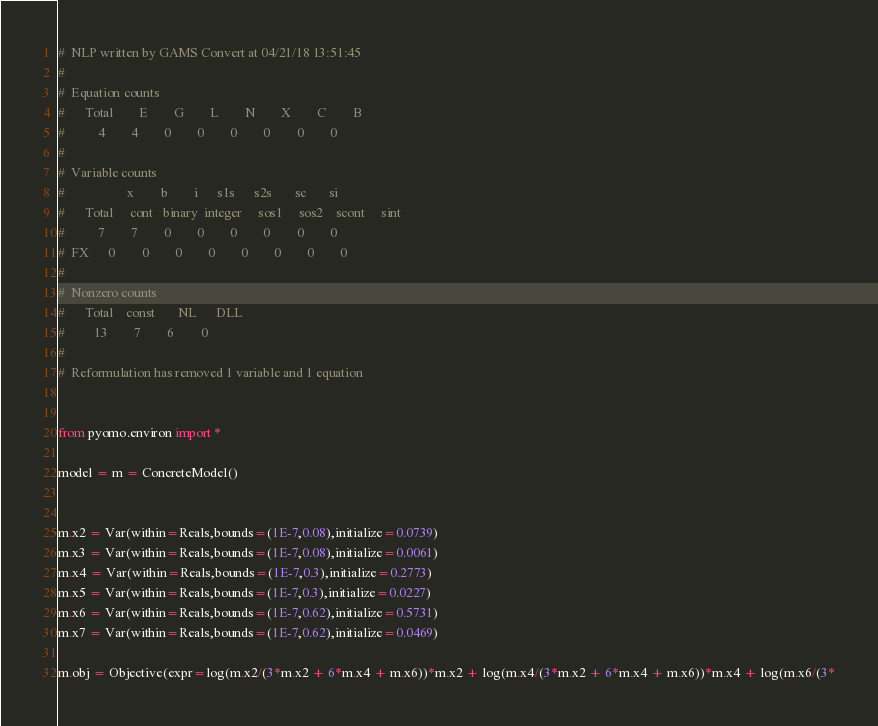<code> <loc_0><loc_0><loc_500><loc_500><_Python_>#  NLP written by GAMS Convert at 04/21/18 13:51:45
#  
#  Equation counts
#      Total        E        G        L        N        X        C        B
#          4        4        0        0        0        0        0        0
#  
#  Variable counts
#                   x        b        i      s1s      s2s       sc       si
#      Total     cont   binary  integer     sos1     sos2    scont     sint
#          7        7        0        0        0        0        0        0
#  FX      0        0        0        0        0        0        0        0
#  
#  Nonzero counts
#      Total    const       NL      DLL
#         13        7        6        0
# 
#  Reformulation has removed 1 variable and 1 equation


from pyomo.environ import *

model = m = ConcreteModel()


m.x2 = Var(within=Reals,bounds=(1E-7,0.08),initialize=0.0739)
m.x3 = Var(within=Reals,bounds=(1E-7,0.08),initialize=0.0061)
m.x4 = Var(within=Reals,bounds=(1E-7,0.3),initialize=0.2773)
m.x5 = Var(within=Reals,bounds=(1E-7,0.3),initialize=0.0227)
m.x6 = Var(within=Reals,bounds=(1E-7,0.62),initialize=0.5731)
m.x7 = Var(within=Reals,bounds=(1E-7,0.62),initialize=0.0469)

m.obj = Objective(expr=log(m.x2/(3*m.x2 + 6*m.x4 + m.x6))*m.x2 + log(m.x4/(3*m.x2 + 6*m.x4 + m.x6))*m.x4 + log(m.x6/(3*</code> 